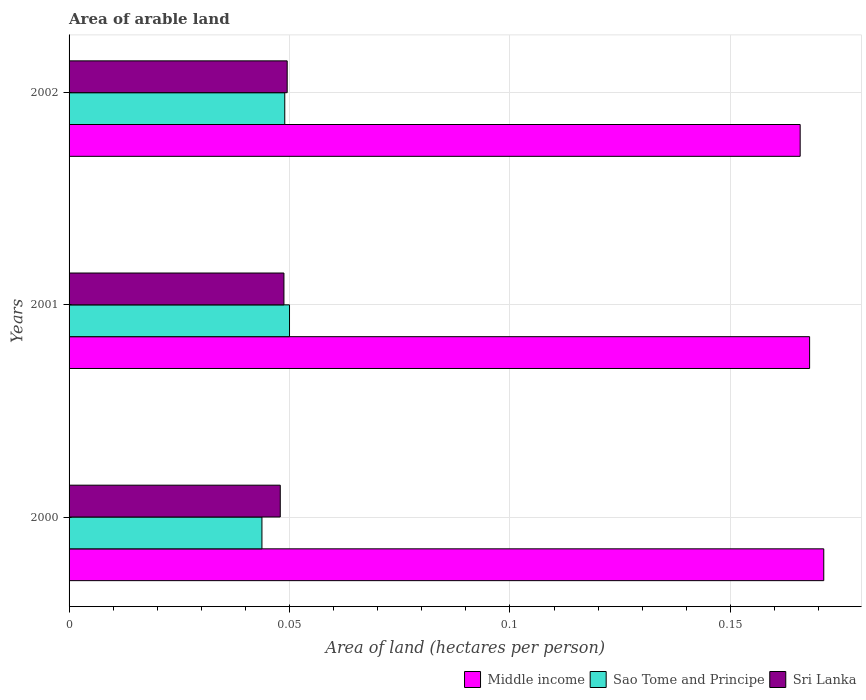How many different coloured bars are there?
Keep it short and to the point. 3. How many groups of bars are there?
Make the answer very short. 3. Are the number of bars per tick equal to the number of legend labels?
Offer a terse response. Yes. What is the label of the 3rd group of bars from the top?
Offer a very short reply. 2000. In how many cases, is the number of bars for a given year not equal to the number of legend labels?
Make the answer very short. 0. What is the total arable land in Middle income in 2000?
Provide a short and direct response. 0.17. Across all years, what is the maximum total arable land in Sao Tome and Principe?
Offer a very short reply. 0.05. Across all years, what is the minimum total arable land in Middle income?
Provide a short and direct response. 0.17. In which year was the total arable land in Middle income minimum?
Make the answer very short. 2002. What is the total total arable land in Middle income in the graph?
Offer a very short reply. 0.5. What is the difference between the total arable land in Sri Lanka in 2001 and that in 2002?
Your response must be concise. -0. What is the difference between the total arable land in Middle income in 2000 and the total arable land in Sri Lanka in 2002?
Make the answer very short. 0.12. What is the average total arable land in Middle income per year?
Keep it short and to the point. 0.17. In the year 2001, what is the difference between the total arable land in Sri Lanka and total arable land in Middle income?
Your response must be concise. -0.12. What is the ratio of the total arable land in Middle income in 2000 to that in 2001?
Keep it short and to the point. 1.02. Is the total arable land in Middle income in 2001 less than that in 2002?
Provide a short and direct response. No. Is the difference between the total arable land in Sri Lanka in 2000 and 2002 greater than the difference between the total arable land in Middle income in 2000 and 2002?
Provide a succinct answer. No. What is the difference between the highest and the second highest total arable land in Sao Tome and Principe?
Make the answer very short. 0. What is the difference between the highest and the lowest total arable land in Sao Tome and Principe?
Your answer should be compact. 0.01. In how many years, is the total arable land in Sao Tome and Principe greater than the average total arable land in Sao Tome and Principe taken over all years?
Your response must be concise. 2. Is the sum of the total arable land in Middle income in 2001 and 2002 greater than the maximum total arable land in Sao Tome and Principe across all years?
Provide a short and direct response. Yes. What does the 1st bar from the top in 2001 represents?
Your response must be concise. Sri Lanka. What does the 2nd bar from the bottom in 2000 represents?
Make the answer very short. Sao Tome and Principe. Is it the case that in every year, the sum of the total arable land in Sri Lanka and total arable land in Sao Tome and Principe is greater than the total arable land in Middle income?
Keep it short and to the point. No. How many bars are there?
Your response must be concise. 9. What is the difference between two consecutive major ticks on the X-axis?
Provide a short and direct response. 0.05. Are the values on the major ticks of X-axis written in scientific E-notation?
Give a very brief answer. No. How are the legend labels stacked?
Make the answer very short. Horizontal. What is the title of the graph?
Offer a very short reply. Area of arable land. Does "Georgia" appear as one of the legend labels in the graph?
Give a very brief answer. No. What is the label or title of the X-axis?
Make the answer very short. Area of land (hectares per person). What is the label or title of the Y-axis?
Offer a very short reply. Years. What is the Area of land (hectares per person) in Middle income in 2000?
Keep it short and to the point. 0.17. What is the Area of land (hectares per person) of Sao Tome and Principe in 2000?
Your response must be concise. 0.04. What is the Area of land (hectares per person) in Sri Lanka in 2000?
Offer a very short reply. 0.05. What is the Area of land (hectares per person) in Middle income in 2001?
Provide a succinct answer. 0.17. What is the Area of land (hectares per person) in Sao Tome and Principe in 2001?
Make the answer very short. 0.05. What is the Area of land (hectares per person) of Sri Lanka in 2001?
Provide a succinct answer. 0.05. What is the Area of land (hectares per person) of Middle income in 2002?
Offer a very short reply. 0.17. What is the Area of land (hectares per person) of Sao Tome and Principe in 2002?
Your answer should be very brief. 0.05. What is the Area of land (hectares per person) in Sri Lanka in 2002?
Your answer should be very brief. 0.05. Across all years, what is the maximum Area of land (hectares per person) in Middle income?
Your answer should be very brief. 0.17. Across all years, what is the maximum Area of land (hectares per person) of Sao Tome and Principe?
Give a very brief answer. 0.05. Across all years, what is the maximum Area of land (hectares per person) of Sri Lanka?
Ensure brevity in your answer.  0.05. Across all years, what is the minimum Area of land (hectares per person) of Middle income?
Keep it short and to the point. 0.17. Across all years, what is the minimum Area of land (hectares per person) of Sao Tome and Principe?
Offer a terse response. 0.04. Across all years, what is the minimum Area of land (hectares per person) of Sri Lanka?
Make the answer very short. 0.05. What is the total Area of land (hectares per person) in Middle income in the graph?
Your answer should be compact. 0.5. What is the total Area of land (hectares per person) in Sao Tome and Principe in the graph?
Provide a succinct answer. 0.14. What is the total Area of land (hectares per person) of Sri Lanka in the graph?
Your response must be concise. 0.15. What is the difference between the Area of land (hectares per person) of Middle income in 2000 and that in 2001?
Ensure brevity in your answer.  0. What is the difference between the Area of land (hectares per person) in Sao Tome and Principe in 2000 and that in 2001?
Ensure brevity in your answer.  -0.01. What is the difference between the Area of land (hectares per person) in Sri Lanka in 2000 and that in 2001?
Give a very brief answer. -0. What is the difference between the Area of land (hectares per person) in Middle income in 2000 and that in 2002?
Make the answer very short. 0.01. What is the difference between the Area of land (hectares per person) of Sao Tome and Principe in 2000 and that in 2002?
Your response must be concise. -0.01. What is the difference between the Area of land (hectares per person) in Sri Lanka in 2000 and that in 2002?
Provide a short and direct response. -0. What is the difference between the Area of land (hectares per person) of Middle income in 2001 and that in 2002?
Offer a terse response. 0. What is the difference between the Area of land (hectares per person) in Sao Tome and Principe in 2001 and that in 2002?
Provide a succinct answer. 0. What is the difference between the Area of land (hectares per person) of Sri Lanka in 2001 and that in 2002?
Make the answer very short. -0. What is the difference between the Area of land (hectares per person) of Middle income in 2000 and the Area of land (hectares per person) of Sao Tome and Principe in 2001?
Your answer should be very brief. 0.12. What is the difference between the Area of land (hectares per person) of Middle income in 2000 and the Area of land (hectares per person) of Sri Lanka in 2001?
Make the answer very short. 0.12. What is the difference between the Area of land (hectares per person) of Sao Tome and Principe in 2000 and the Area of land (hectares per person) of Sri Lanka in 2001?
Your response must be concise. -0.01. What is the difference between the Area of land (hectares per person) of Middle income in 2000 and the Area of land (hectares per person) of Sao Tome and Principe in 2002?
Your answer should be compact. 0.12. What is the difference between the Area of land (hectares per person) of Middle income in 2000 and the Area of land (hectares per person) of Sri Lanka in 2002?
Make the answer very short. 0.12. What is the difference between the Area of land (hectares per person) of Sao Tome and Principe in 2000 and the Area of land (hectares per person) of Sri Lanka in 2002?
Ensure brevity in your answer.  -0.01. What is the difference between the Area of land (hectares per person) of Middle income in 2001 and the Area of land (hectares per person) of Sao Tome and Principe in 2002?
Your answer should be compact. 0.12. What is the difference between the Area of land (hectares per person) in Middle income in 2001 and the Area of land (hectares per person) in Sri Lanka in 2002?
Keep it short and to the point. 0.12. What is the average Area of land (hectares per person) in Middle income per year?
Make the answer very short. 0.17. What is the average Area of land (hectares per person) of Sao Tome and Principe per year?
Your response must be concise. 0.05. What is the average Area of land (hectares per person) in Sri Lanka per year?
Your response must be concise. 0.05. In the year 2000, what is the difference between the Area of land (hectares per person) of Middle income and Area of land (hectares per person) of Sao Tome and Principe?
Provide a succinct answer. 0.13. In the year 2000, what is the difference between the Area of land (hectares per person) in Middle income and Area of land (hectares per person) in Sri Lanka?
Your answer should be compact. 0.12. In the year 2000, what is the difference between the Area of land (hectares per person) in Sao Tome and Principe and Area of land (hectares per person) in Sri Lanka?
Keep it short and to the point. -0. In the year 2001, what is the difference between the Area of land (hectares per person) in Middle income and Area of land (hectares per person) in Sao Tome and Principe?
Keep it short and to the point. 0.12. In the year 2001, what is the difference between the Area of land (hectares per person) in Middle income and Area of land (hectares per person) in Sri Lanka?
Ensure brevity in your answer.  0.12. In the year 2001, what is the difference between the Area of land (hectares per person) in Sao Tome and Principe and Area of land (hectares per person) in Sri Lanka?
Provide a succinct answer. 0. In the year 2002, what is the difference between the Area of land (hectares per person) of Middle income and Area of land (hectares per person) of Sao Tome and Principe?
Offer a terse response. 0.12. In the year 2002, what is the difference between the Area of land (hectares per person) of Middle income and Area of land (hectares per person) of Sri Lanka?
Your answer should be very brief. 0.12. In the year 2002, what is the difference between the Area of land (hectares per person) of Sao Tome and Principe and Area of land (hectares per person) of Sri Lanka?
Your answer should be compact. -0. What is the ratio of the Area of land (hectares per person) of Middle income in 2000 to that in 2001?
Provide a short and direct response. 1.02. What is the ratio of the Area of land (hectares per person) of Sao Tome and Principe in 2000 to that in 2001?
Give a very brief answer. 0.87. What is the ratio of the Area of land (hectares per person) of Sri Lanka in 2000 to that in 2001?
Provide a succinct answer. 0.98. What is the ratio of the Area of land (hectares per person) of Middle income in 2000 to that in 2002?
Your response must be concise. 1.03. What is the ratio of the Area of land (hectares per person) in Sao Tome and Principe in 2000 to that in 2002?
Your answer should be very brief. 0.89. What is the ratio of the Area of land (hectares per person) in Sri Lanka in 2000 to that in 2002?
Give a very brief answer. 0.97. What is the ratio of the Area of land (hectares per person) in Middle income in 2001 to that in 2002?
Ensure brevity in your answer.  1.01. What is the ratio of the Area of land (hectares per person) of Sao Tome and Principe in 2001 to that in 2002?
Keep it short and to the point. 1.02. What is the ratio of the Area of land (hectares per person) in Sri Lanka in 2001 to that in 2002?
Offer a terse response. 0.99. What is the difference between the highest and the second highest Area of land (hectares per person) of Middle income?
Your response must be concise. 0. What is the difference between the highest and the second highest Area of land (hectares per person) of Sao Tome and Principe?
Make the answer very short. 0. What is the difference between the highest and the second highest Area of land (hectares per person) of Sri Lanka?
Your answer should be compact. 0. What is the difference between the highest and the lowest Area of land (hectares per person) in Middle income?
Offer a very short reply. 0.01. What is the difference between the highest and the lowest Area of land (hectares per person) of Sao Tome and Principe?
Your answer should be very brief. 0.01. What is the difference between the highest and the lowest Area of land (hectares per person) in Sri Lanka?
Provide a short and direct response. 0. 